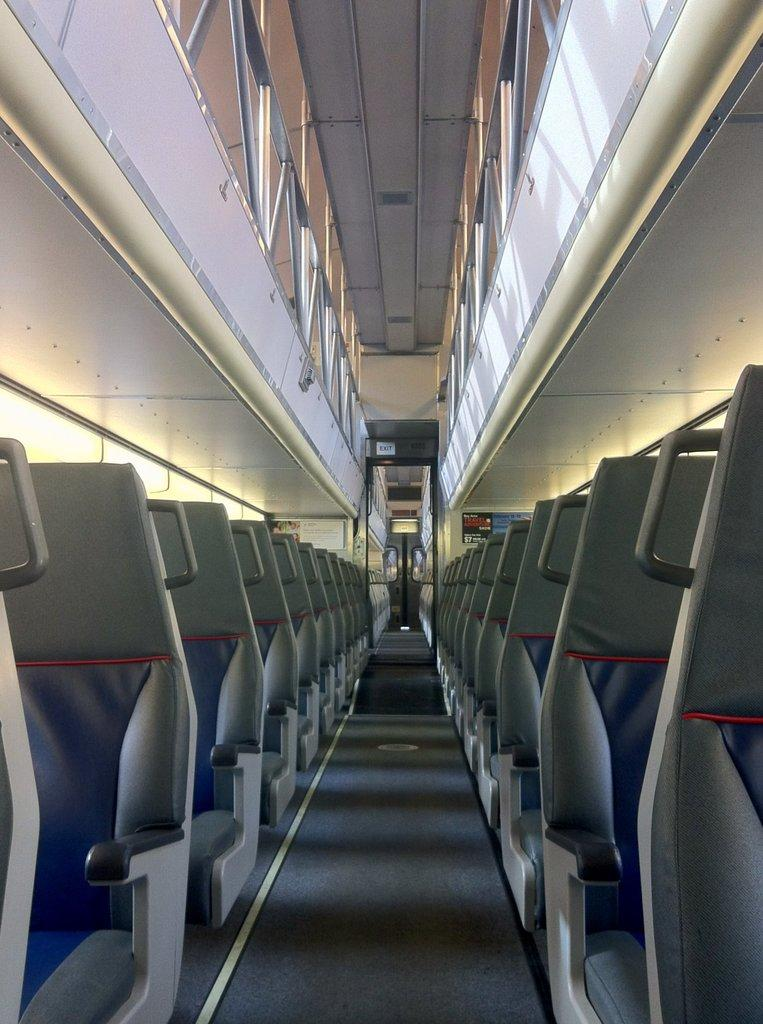What type of furniture can be seen in the image? There are sitting chairs in the image. How many chairs are visible in the image? The number of chairs is not specified, but there are sitting chairs present. What might the chairs be used for? The chairs are likely used for sitting or resting. What type of club is being used to make a statement in the image? There is no club or statement present in the image; it only features sitting chairs. 